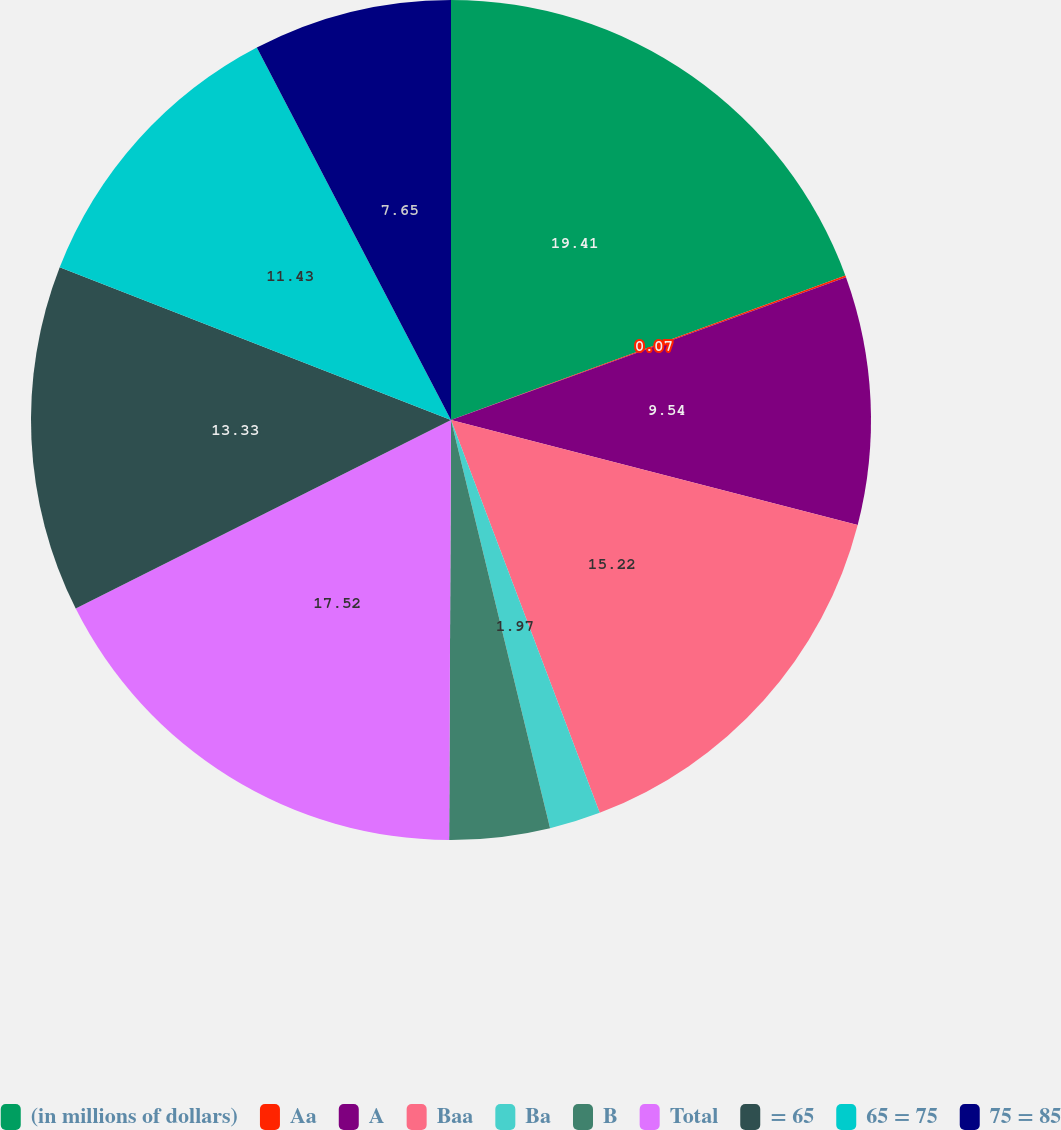Convert chart to OTSL. <chart><loc_0><loc_0><loc_500><loc_500><pie_chart><fcel>(in millions of dollars)<fcel>Aa<fcel>A<fcel>Baa<fcel>Ba<fcel>B<fcel>Total<fcel>= 65<fcel>65 = 75<fcel>75 = 85<nl><fcel>19.41%<fcel>0.07%<fcel>9.54%<fcel>15.22%<fcel>1.97%<fcel>3.86%<fcel>17.52%<fcel>13.33%<fcel>11.43%<fcel>7.65%<nl></chart> 